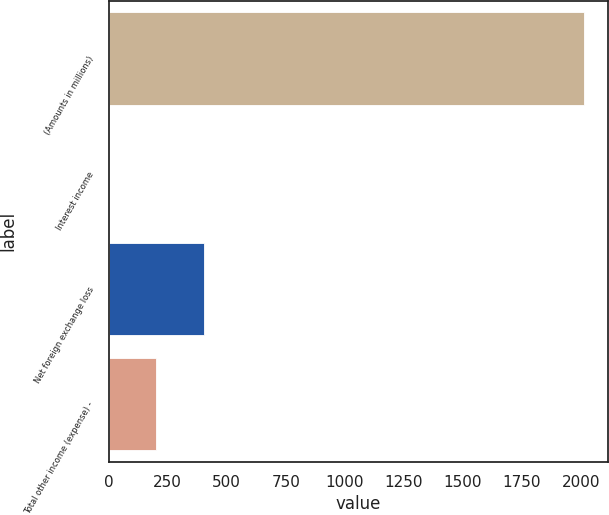Convert chart to OTSL. <chart><loc_0><loc_0><loc_500><loc_500><bar_chart><fcel>(Amounts in millions)<fcel>Interest income<fcel>Net foreign exchange loss<fcel>Total other income (expense) -<nl><fcel>2013<fcel>0.5<fcel>403<fcel>201.75<nl></chart> 